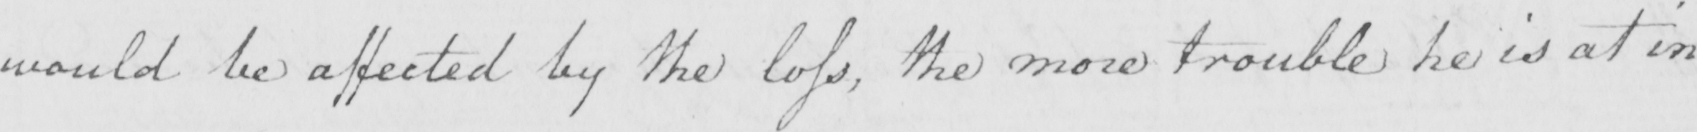What does this handwritten line say? would be affected by the loss , the more trouble he is at in 